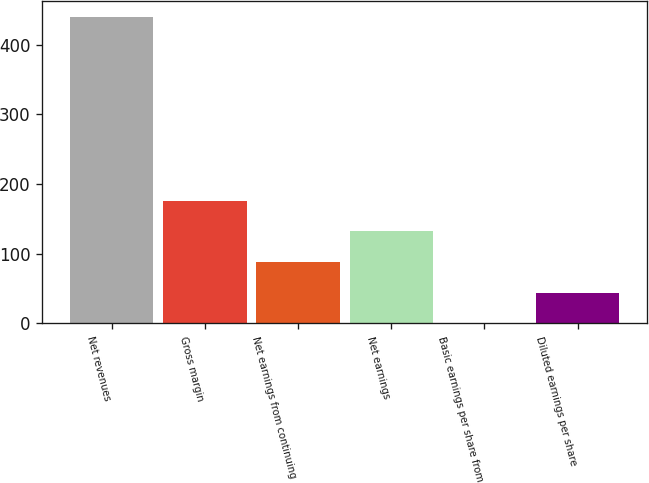<chart> <loc_0><loc_0><loc_500><loc_500><bar_chart><fcel>Net revenues<fcel>Gross margin<fcel>Net earnings from continuing<fcel>Net earnings<fcel>Basic earnings per share from<fcel>Diluted earnings per share<nl><fcel>440.1<fcel>176.17<fcel>88.19<fcel>132.18<fcel>0.21<fcel>44.2<nl></chart> 